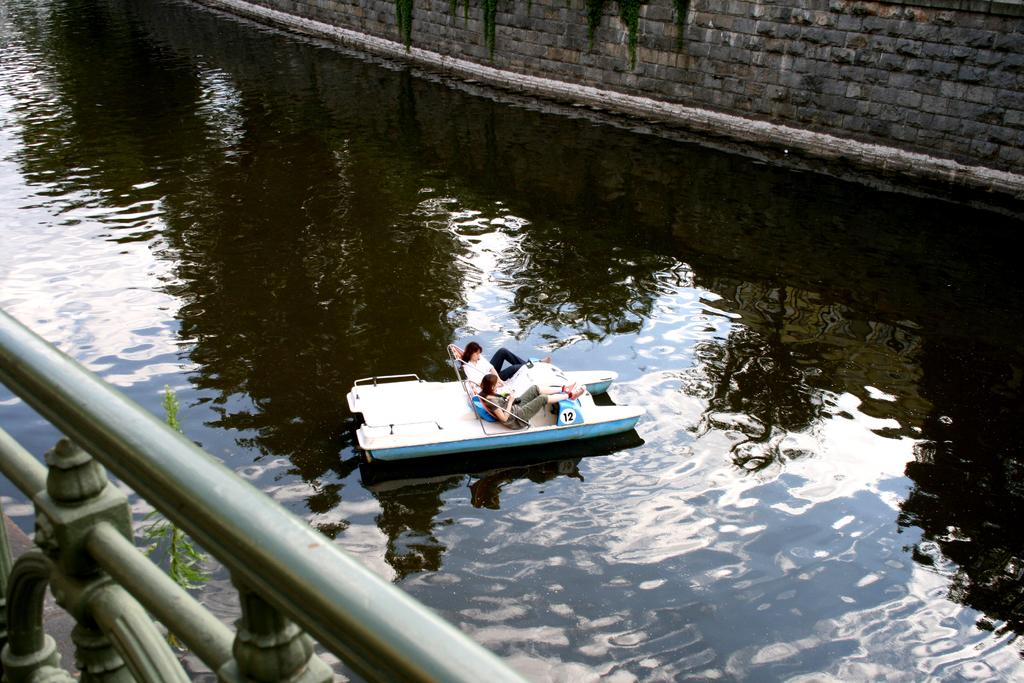What are the two main subjects in the image? There are two ladies in a boat in the center of the image. What is the primary setting of the image? There is water visible in the image. What can be seen in the background of the image? There is a wall in the background of the image. What is on the left side of the image? There is a railing on the left side of the image. How many trucks are parked near the jail in the image? There are no trucks or jail present in the image. 